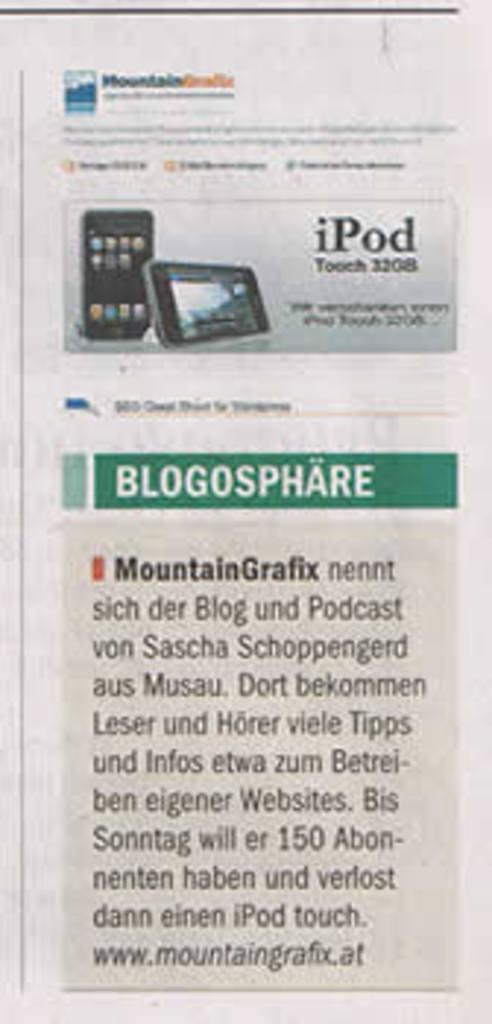What item is advertised in this clipping?
Ensure brevity in your answer.  Ipod. Whats the advert about?
Keep it short and to the point. Ipod. 